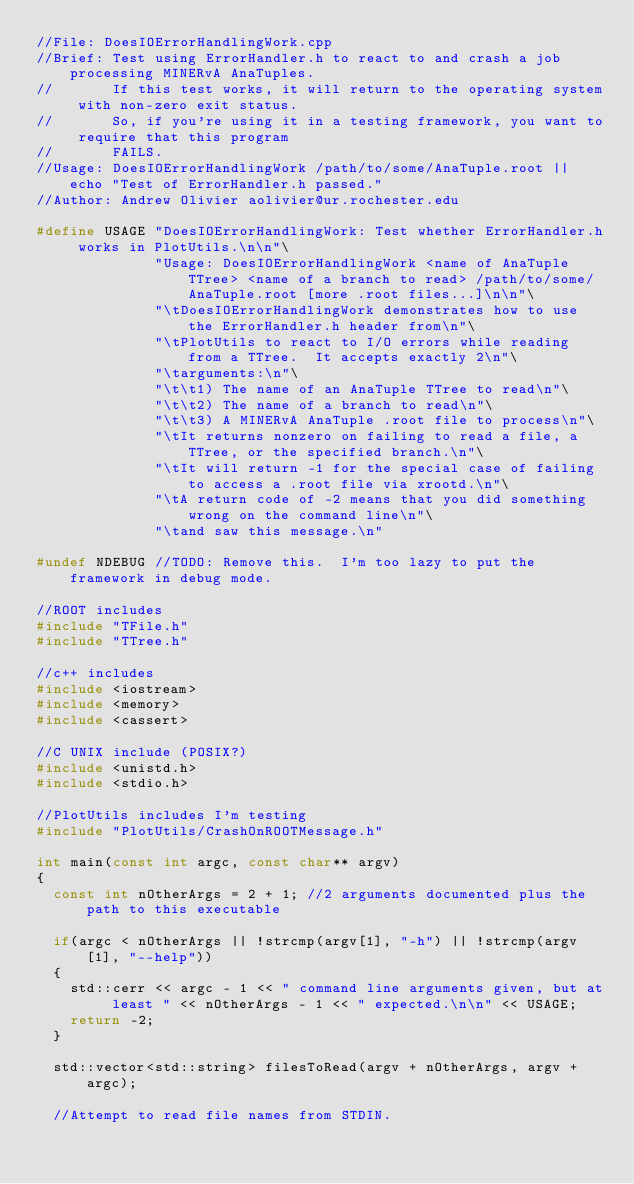Convert code to text. <code><loc_0><loc_0><loc_500><loc_500><_C++_>//File: DoesIOErrorHandlingWork.cpp
//Brief: Test using ErrorHandler.h to react to and crash a job processing MINERvA AnaTuples.
//       If this test works, it will return to the operating system with non-zero exit status.
//       So, if you're using it in a testing framework, you want to require that this program
//       FAILS.
//Usage: DoesIOErrorHandlingWork /path/to/some/AnaTuple.root || echo "Test of ErrorHandler.h passed."
//Author: Andrew Olivier aolivier@ur.rochester.edu

#define USAGE "DoesIOErrorHandlingWork: Test whether ErrorHandler.h works in PlotUtils.\n\n"\
              "Usage: DoesIOErrorHandlingWork <name of AnaTuple TTree> <name of a branch to read> /path/to/some/AnaTuple.root [more .root files...]\n\n"\
              "\tDoesIOErrorHandlingWork demonstrates how to use the ErrorHandler.h header from\n"\
              "\tPlotUtils to react to I/O errors while reading from a TTree.  It accepts exactly 2\n"\
              "\targuments:\n"\
              "\t\t1) The name of an AnaTuple TTree to read\n"\
              "\t\t2) The name of a branch to read\n"\
              "\t\t3) A MINERvA AnaTuple .root file to process\n"\
              "\tIt returns nonzero on failing to read a file, a TTree, or the specified branch.\n"\
              "\tIt will return -1 for the special case of failing to access a .root file via xrootd.\n"\
              "\tA return code of -2 means that you did something wrong on the command line\n"\
              "\tand saw this message.\n"

#undef NDEBUG //TODO: Remove this.  I'm too lazy to put the framework in debug mode.

//ROOT includes
#include "TFile.h"
#include "TTree.h"

//c++ includes
#include <iostream>
#include <memory>
#include <cassert>

//C UNIX include (POSIX?)
#include <unistd.h>
#include <stdio.h>

//PlotUtils includes I'm testing
#include "PlotUtils/CrashOnROOTMessage.h"

int main(const int argc, const char** argv)
{
  const int nOtherArgs = 2 + 1; //2 arguments documented plus the path to this executable

  if(argc < nOtherArgs || !strcmp(argv[1], "-h") || !strcmp(argv[1], "--help"))
  {
    std::cerr << argc - 1 << " command line arguments given, but at least " << nOtherArgs - 1 << " expected.\n\n" << USAGE;
    return -2;
  }

  std::vector<std::string> filesToRead(argv + nOtherArgs, argv + argc);

  //Attempt to read file names from STDIN.</code> 